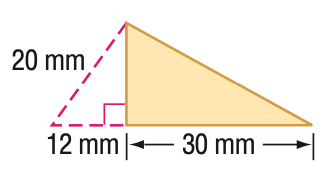Question: Find the perimeter of the triangle. Round to the nearest tenth if necessary.
Choices:
A. 62
B. 76
C. 80
D. 91.3
Answer with the letter. Answer: C Question: Find the area of the triangle. Round to the nearest tenth if necessary.
Choices:
A. 180
B. 240
C. 360
D. 480
Answer with the letter. Answer: B 